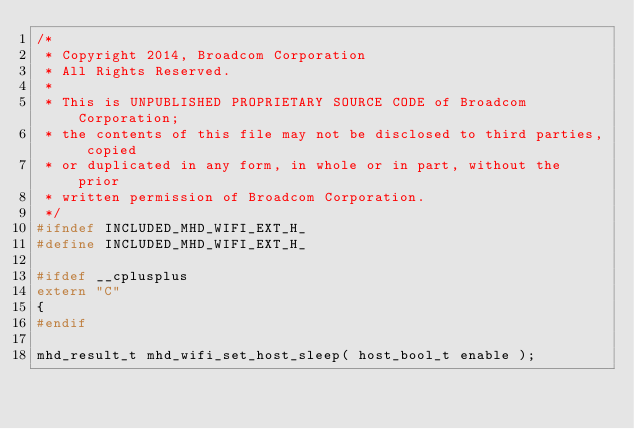Convert code to text. <code><loc_0><loc_0><loc_500><loc_500><_C_>/*
 * Copyright 2014, Broadcom Corporation
 * All Rights Reserved.
 *
 * This is UNPUBLISHED PROPRIETARY SOURCE CODE of Broadcom Corporation;
 * the contents of this file may not be disclosed to third parties, copied
 * or duplicated in any form, in whole or in part, without the prior
 * written permission of Broadcom Corporation.
 */
#ifndef INCLUDED_MHD_WIFI_EXT_H_
#define INCLUDED_MHD_WIFI_EXT_H_

#ifdef __cplusplus
extern "C"
{
#endif

mhd_result_t mhd_wifi_set_host_sleep( host_bool_t enable );</code> 